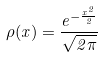<formula> <loc_0><loc_0><loc_500><loc_500>\rho ( x ) = \frac { e ^ { - \frac { x ^ { 2 } } { 2 } } } { \sqrt { 2 \pi } }</formula> 